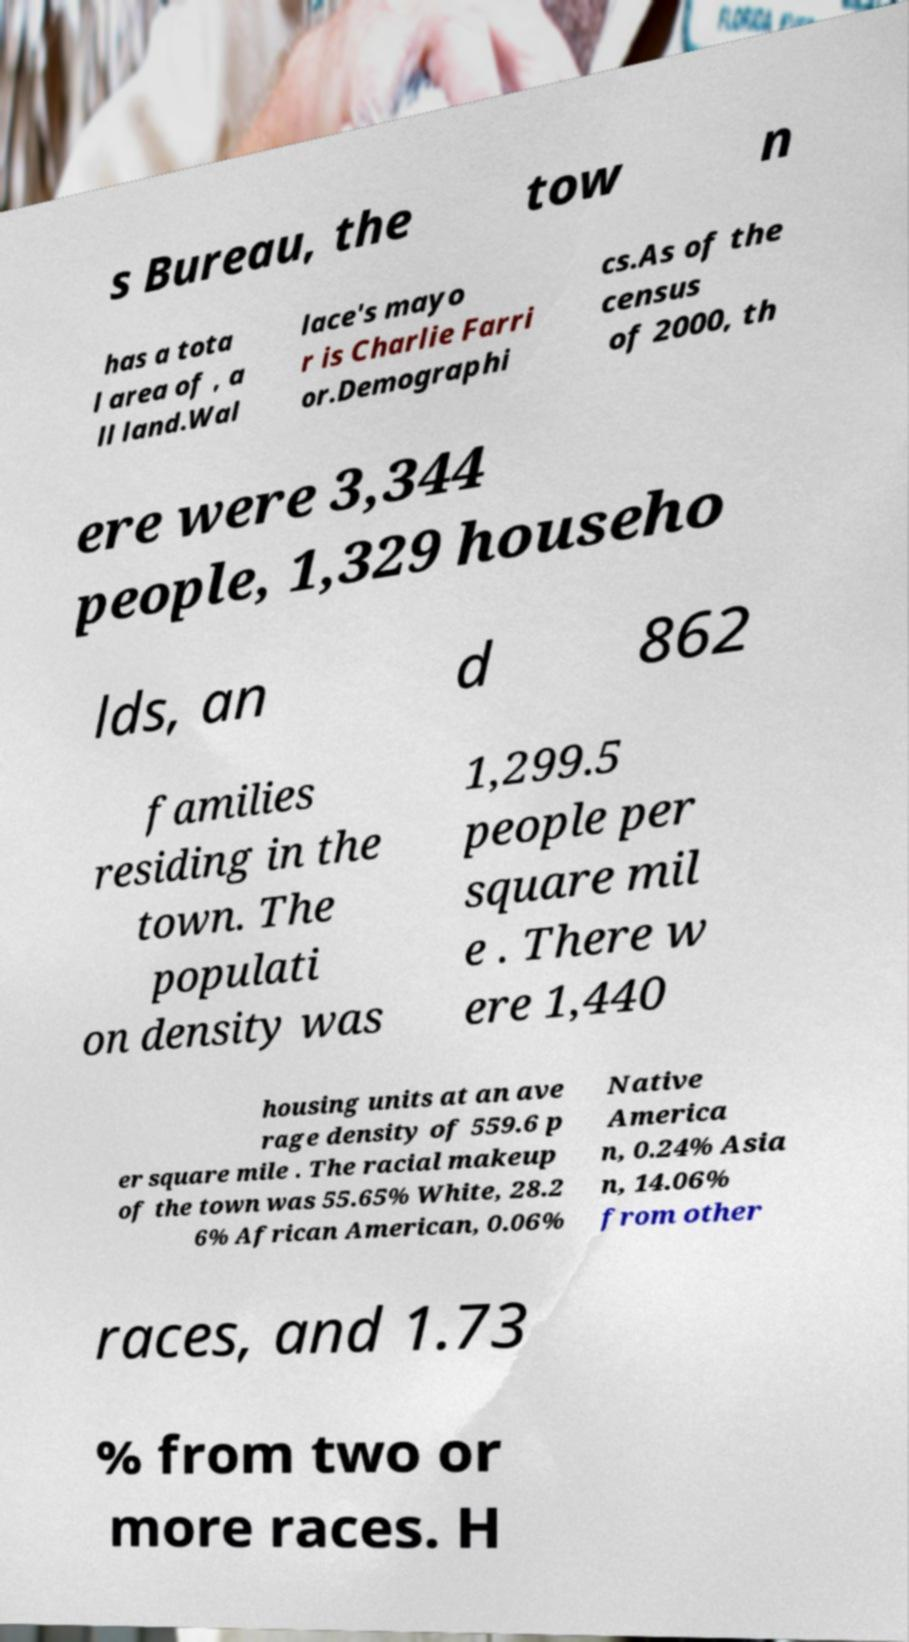Please identify and transcribe the text found in this image. s Bureau, the tow n has a tota l area of , a ll land.Wal lace's mayo r is Charlie Farri or.Demographi cs.As of the census of 2000, th ere were 3,344 people, 1,329 househo lds, an d 862 families residing in the town. The populati on density was 1,299.5 people per square mil e . There w ere 1,440 housing units at an ave rage density of 559.6 p er square mile . The racial makeup of the town was 55.65% White, 28.2 6% African American, 0.06% Native America n, 0.24% Asia n, 14.06% from other races, and 1.73 % from two or more races. H 